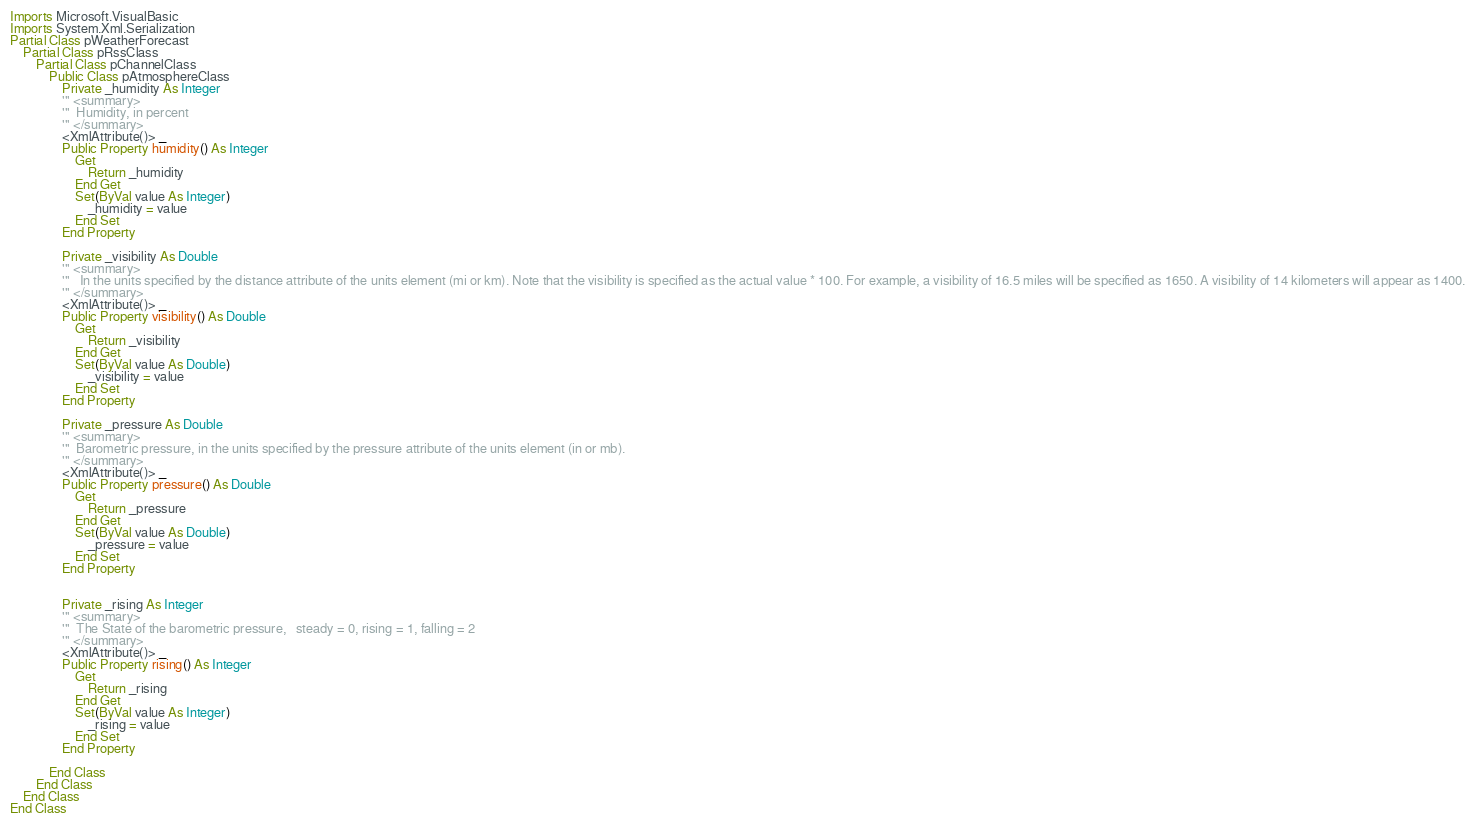<code> <loc_0><loc_0><loc_500><loc_500><_VisualBasic_>Imports Microsoft.VisualBasic
Imports System.Xml.Serialization
Partial Class pWeatherForecast
    Partial Class pRssClass
        Partial Class pChannelClass
            Public Class pAtmosphereClass
                Private _humidity As Integer
                ''' <summary>
                '''  Humidity, in percent 
                ''' </summary>
                <XmlAttribute()> _
                Public Property humidity() As Integer
                    Get
                        Return _humidity
                    End Get
                    Set(ByVal value As Integer)
                        _humidity = value
                    End Set
                End Property

                Private _visibility As Double
                ''' <summary>
                '''   In the units specified by the distance attribute of the units element (mi or km). Note that the visibility is specified as the actual value * 100. For example, a visibility of 16.5 miles will be specified as 1650. A visibility of 14 kilometers will appear as 1400. 
                ''' </summary>
                <XmlAttribute()> _
                Public Property visibility() As Double
                    Get
                        Return _visibility
                    End Get
                    Set(ByVal value As Double)
                        _visibility = value
                    End Set
                End Property

                Private _pressure As Double
                ''' <summary>
                '''  Barometric pressure, in the units specified by the pressure attribute of the units element (in or mb).
                ''' </summary>
                <XmlAttribute()> _
                Public Property pressure() As Double
                    Get
                        Return _pressure
                    End Get
                    Set(ByVal value As Double)
                        _pressure = value
                    End Set
                End Property


                Private _rising As Integer
                ''' <summary>
                '''  The State of the barometric pressure,   steady = 0, rising = 1, falling = 2
                ''' </summary>
                <XmlAttribute()> _
                Public Property rising() As Integer
                    Get
                        Return _rising
                    End Get
                    Set(ByVal value As Integer)
                        _rising = value
                    End Set
                End Property

            End Class
        End Class
    End Class
End Class
</code> 